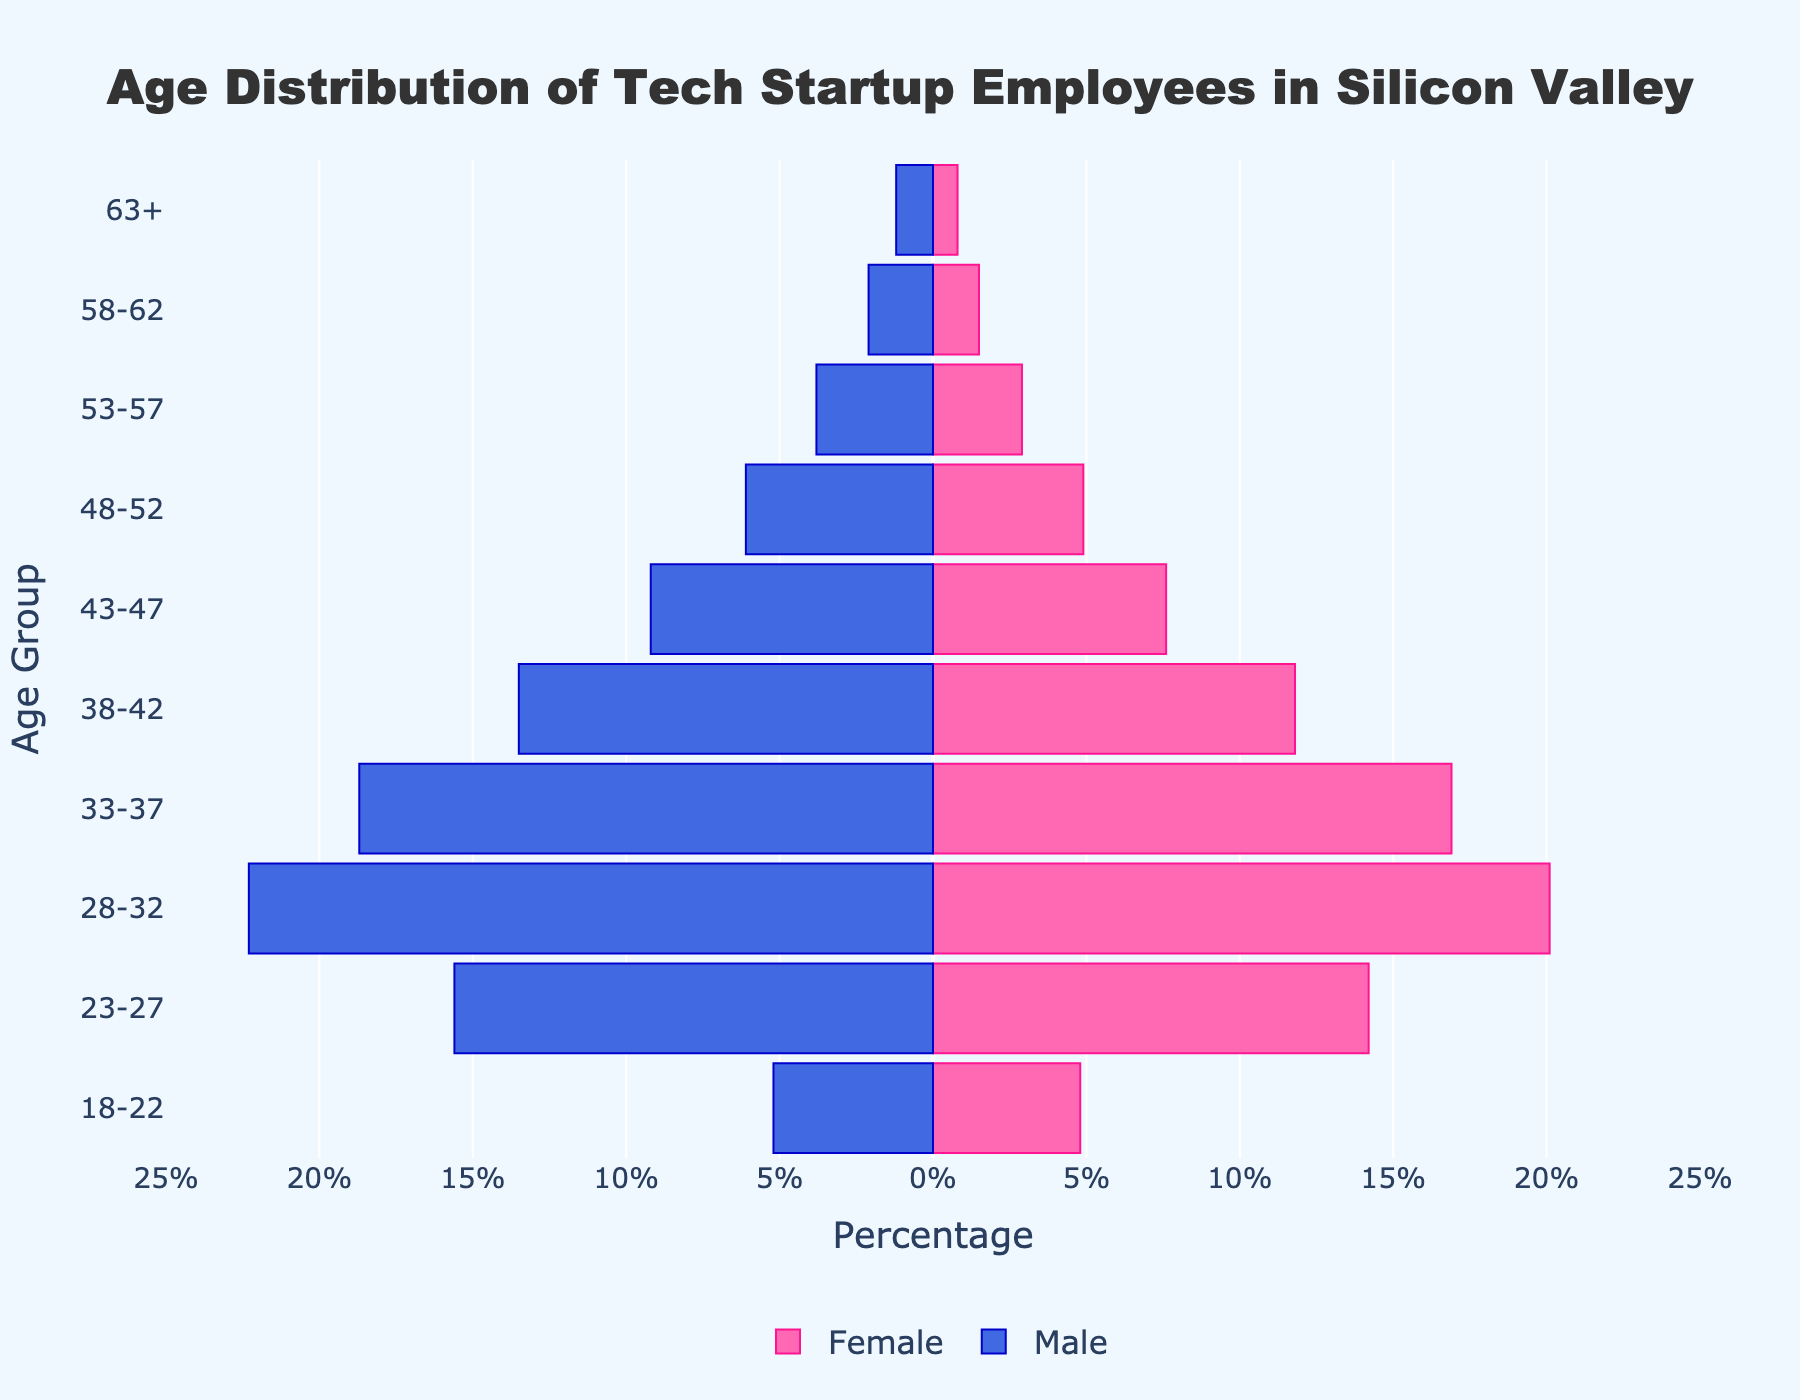What is the title of the plot? The title of the plot is located at the top center of the figure. It reads "Age Distribution of Tech Startup Employees in Silicon Valley".
Answer: Age Distribution of Tech Startup Employees in Silicon Valley Which gender has a higher percentage in the 28-32 age group? By examining the plot, the bars representing the 28-32 age group can be compared. The bar on the left indicates males and the bar on the right indicates females. The male percentage is higher at 22.3% compared to the female percentage of 20.1%.
Answer: Male What is the smallest age group percentage for females? Looking at the right side of the figure, which represents female percentages, the smallest bar reaches 0.8% for the 63+ age group.
Answer: 0.8% Add the percentages of males and females in the 38-42 age group. What is the total? The figure shows 13.5% for males and 11.8% for females in the 38-42 age group. Adding these gives 13.5% + 11.8% = 25.3%.
Answer: 25.3% How many age groups have a higher male percentage than female percentage? By examining each age group, the male percentage is higher than the female percentage in every age group except 63+, where males are 1.2% and females are 0.8%. Therefore, 9 age groups show higher male percentages.
Answer: 9 Which age group has the most balanced gender distribution? The most balanced distribution can be found by comparing the bars for both genders for each age group and finding the smallest difference. The 18-22 age group has the closest values with 5.2% males and 4.8% females.
Answer: 18-22 Compare the percentages of males and females in the 23-27 and 53-57 age groups. Which age group shows a greater difference between genders? For 23-27, males are 15.6% and females are 14.2%, resulting in a difference of 1.4%. For 53-57, males are 3.8% and females are 2.9%, giving a difference of 0.9%. Thus, the 23-27 age group shows a greater difference.
Answer: 23-27 What is the total percentage of employees aged 33-37? Adding the percentages for males (18.7%) and females (16.9%) in the 33-37 age group gives a total of 18.7% + 16.9% = 35.6%.
Answer: 35.6% What proportion of the total population is represented by males aged 43-47? The percentage of males in the 43-47 age group is shown as 9.2%. Since the figure uses percentages, this means 9.2% of the total population.
Answer: 9.2% At which age group does the ratio of males to females first fall below 2:1? Calculating the ratios for each age group:  
- 18-22: 5.2/4.8 ≈ 1.08
- 23-27: 15.6/14.2 ≈ 1.10
- 28-32: 22.3/20.1 ≈ 1.11
- 33-37: 18.7/16.9 ≈ 1.11
- 38-42: 13.5/11.8 ≈ 1.14
- 43-47: 9.2/7.6 ≈ 1.21
- 48-52: 6.1/4.9 ≈ 1.24
- 53-57: 3.8/2.9 ≈ 1.31
- 58-62: 2.1/1.5 ≈ 1.40
- 63+: 1.2/0.8 = 1.5
  
None of the listed age groups have a ratio falling below 2:1; returned largest age group.
Answer: 18-22 